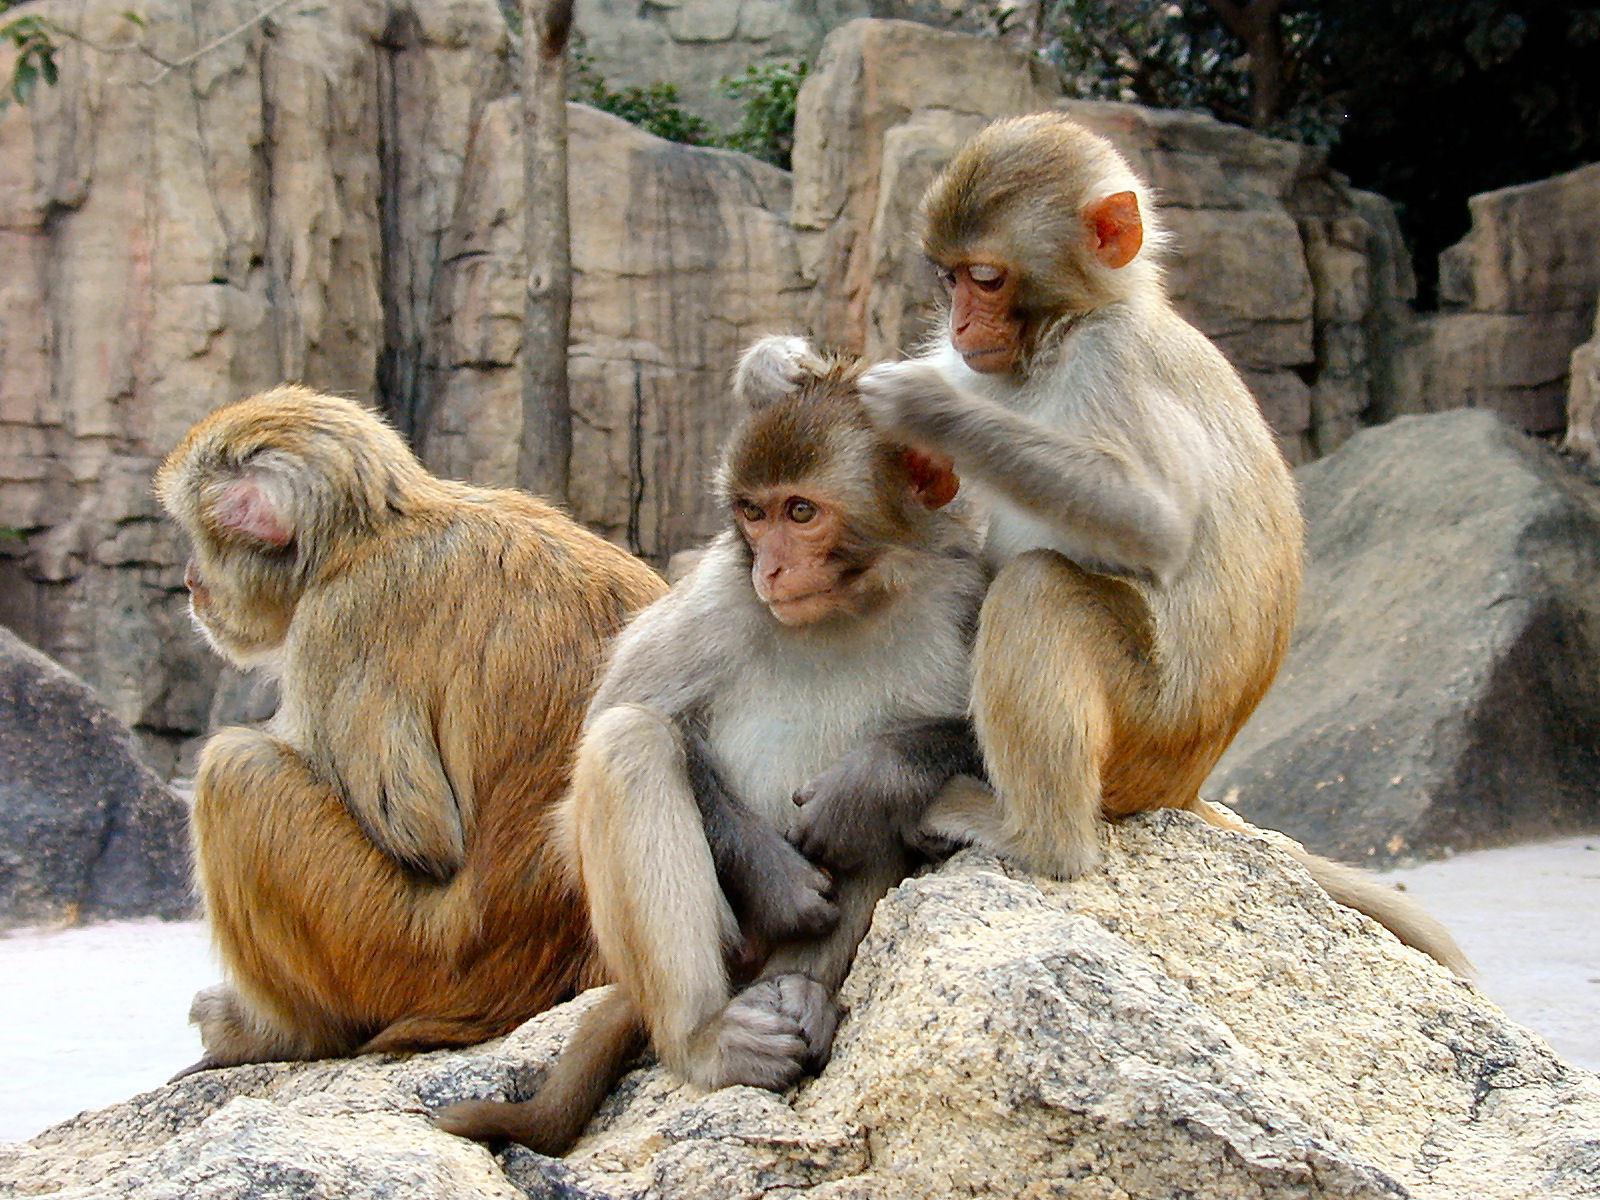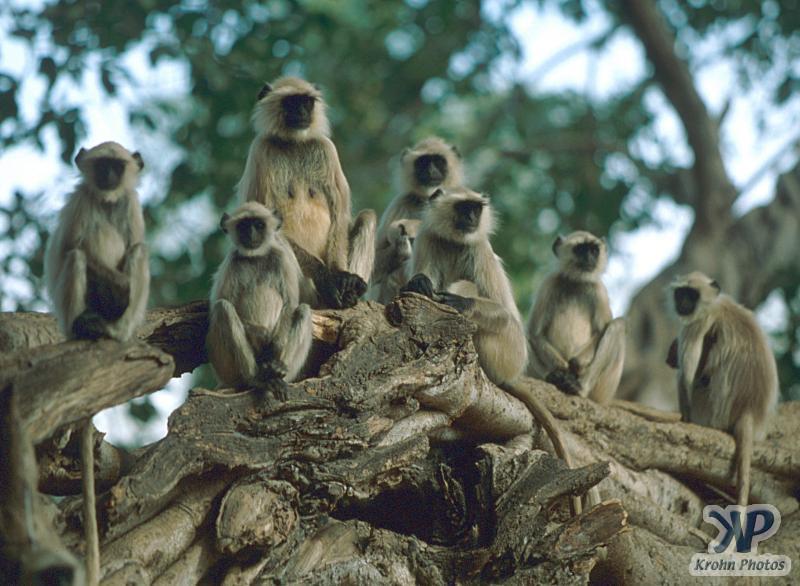The first image is the image on the left, the second image is the image on the right. Given the left and right images, does the statement "There are no more than 6 monkeys in the image on the left." hold true? Answer yes or no. Yes. 